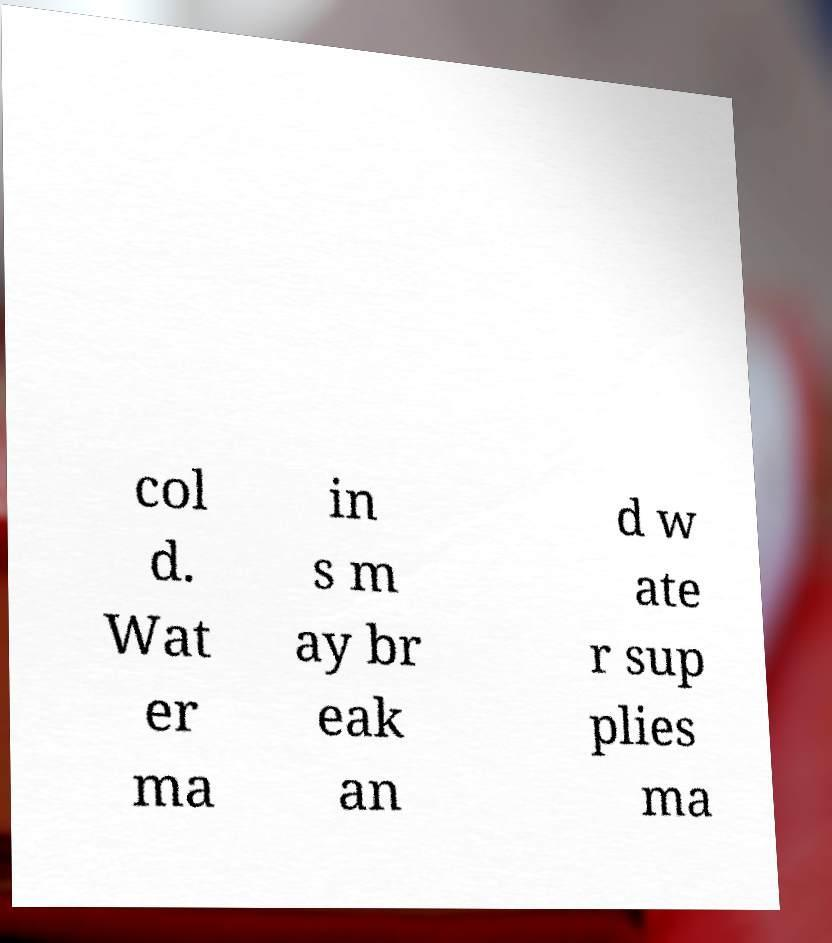What messages or text are displayed in this image? I need them in a readable, typed format. col d. Wat er ma in s m ay br eak an d w ate r sup plies ma 